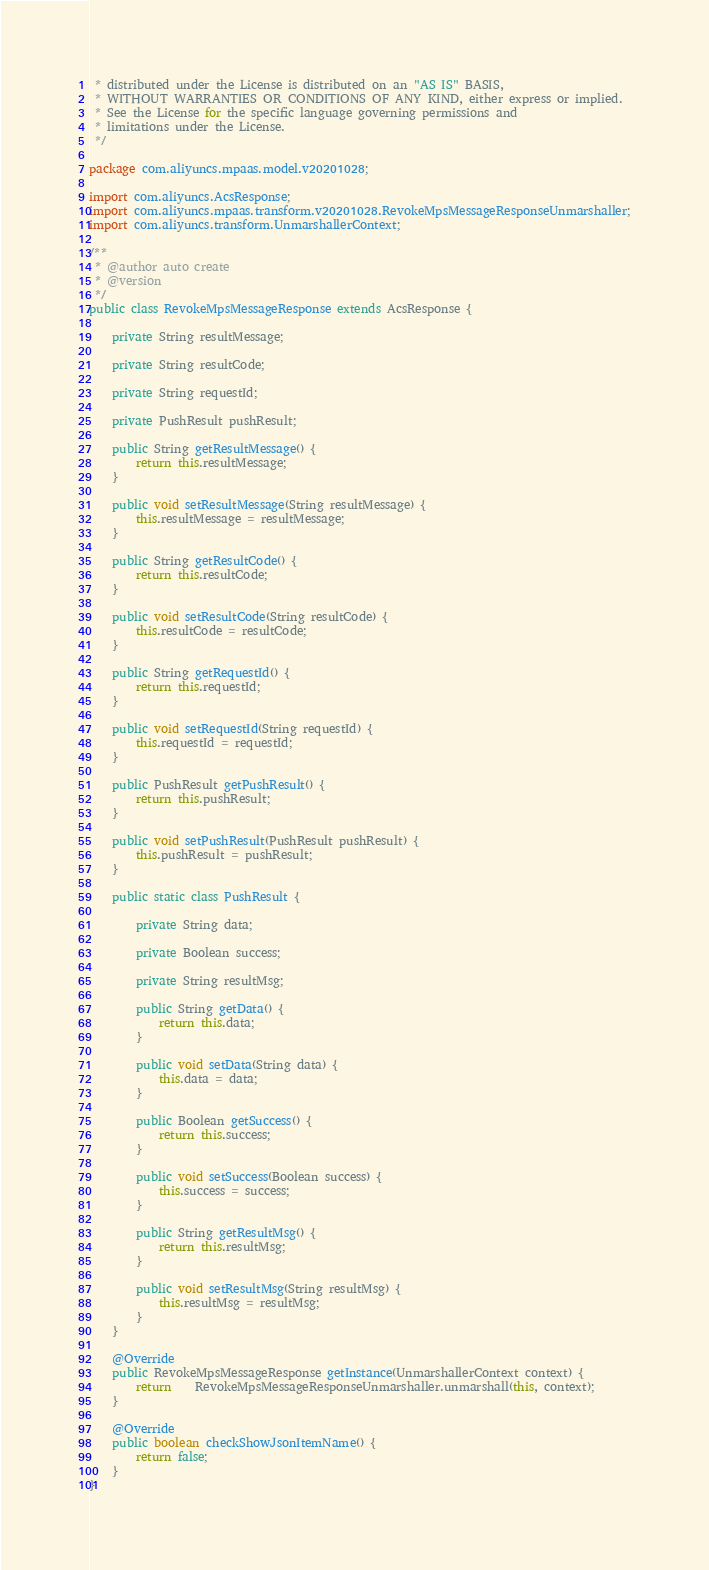Convert code to text. <code><loc_0><loc_0><loc_500><loc_500><_Java_> * distributed under the License is distributed on an "AS IS" BASIS,
 * WITHOUT WARRANTIES OR CONDITIONS OF ANY KIND, either express or implied.
 * See the License for the specific language governing permissions and
 * limitations under the License.
 */

package com.aliyuncs.mpaas.model.v20201028;

import com.aliyuncs.AcsResponse;
import com.aliyuncs.mpaas.transform.v20201028.RevokeMpsMessageResponseUnmarshaller;
import com.aliyuncs.transform.UnmarshallerContext;

/**
 * @author auto create
 * @version 
 */
public class RevokeMpsMessageResponse extends AcsResponse {

	private String resultMessage;

	private String resultCode;

	private String requestId;

	private PushResult pushResult;

	public String getResultMessage() {
		return this.resultMessage;
	}

	public void setResultMessage(String resultMessage) {
		this.resultMessage = resultMessage;
	}

	public String getResultCode() {
		return this.resultCode;
	}

	public void setResultCode(String resultCode) {
		this.resultCode = resultCode;
	}

	public String getRequestId() {
		return this.requestId;
	}

	public void setRequestId(String requestId) {
		this.requestId = requestId;
	}

	public PushResult getPushResult() {
		return this.pushResult;
	}

	public void setPushResult(PushResult pushResult) {
		this.pushResult = pushResult;
	}

	public static class PushResult {

		private String data;

		private Boolean success;

		private String resultMsg;

		public String getData() {
			return this.data;
		}

		public void setData(String data) {
			this.data = data;
		}

		public Boolean getSuccess() {
			return this.success;
		}

		public void setSuccess(Boolean success) {
			this.success = success;
		}

		public String getResultMsg() {
			return this.resultMsg;
		}

		public void setResultMsg(String resultMsg) {
			this.resultMsg = resultMsg;
		}
	}

	@Override
	public RevokeMpsMessageResponse getInstance(UnmarshallerContext context) {
		return	RevokeMpsMessageResponseUnmarshaller.unmarshall(this, context);
	}

	@Override
	public boolean checkShowJsonItemName() {
		return false;
	}
}
</code> 